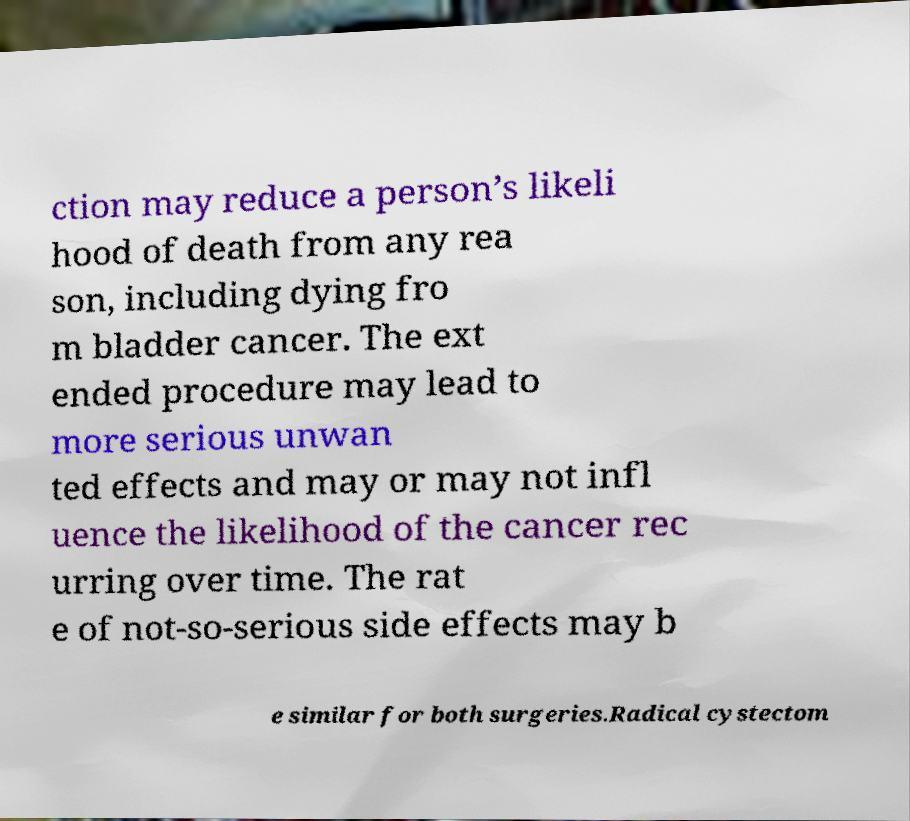There's text embedded in this image that I need extracted. Can you transcribe it verbatim? ction may reduce a person’s likeli hood of death from any rea son, including dying fro m bladder cancer. The ext ended procedure may lead to more serious unwan ted effects and may or may not infl uence the likelihood of the cancer rec urring over time. The rat e of not-so-serious side effects may b e similar for both surgeries.Radical cystectom 